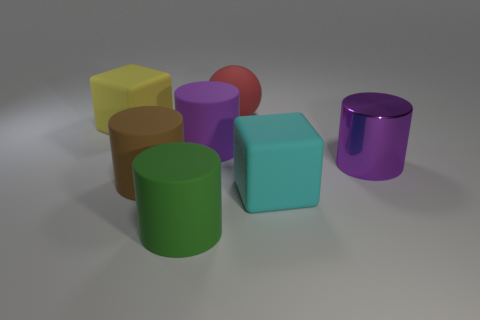Subtract all large purple metal cylinders. How many cylinders are left? 3 Subtract 1 blocks. How many blocks are left? 1 Add 3 green rubber objects. How many objects exist? 10 Subtract all cyan cubes. How many cubes are left? 1 Subtract all cubes. How many objects are left? 5 Subtract 0 blue cylinders. How many objects are left? 7 Subtract all green blocks. Subtract all cyan spheres. How many blocks are left? 2 Subtract all red cylinders. How many cyan cubes are left? 1 Subtract all big red balls. Subtract all large purple metallic cylinders. How many objects are left? 5 Add 3 rubber cubes. How many rubber cubes are left? 5 